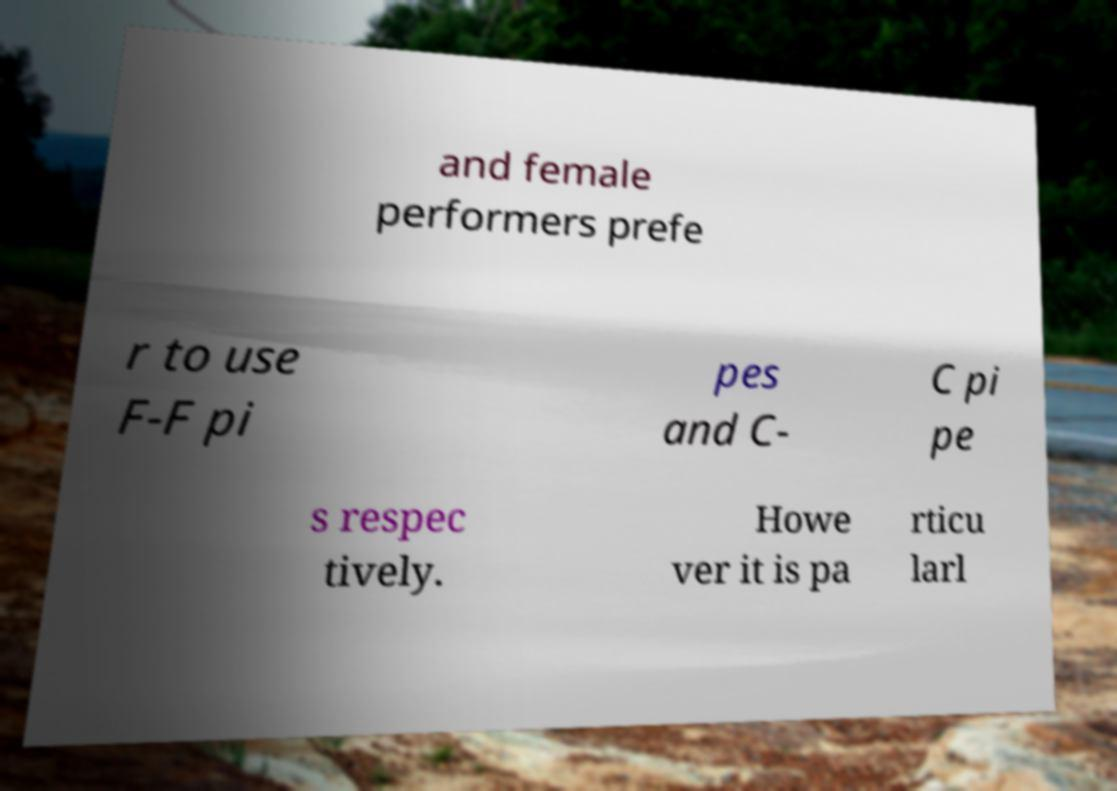For documentation purposes, I need the text within this image transcribed. Could you provide that? and female performers prefe r to use F-F pi pes and C- C pi pe s respec tively. Howe ver it is pa rticu larl 